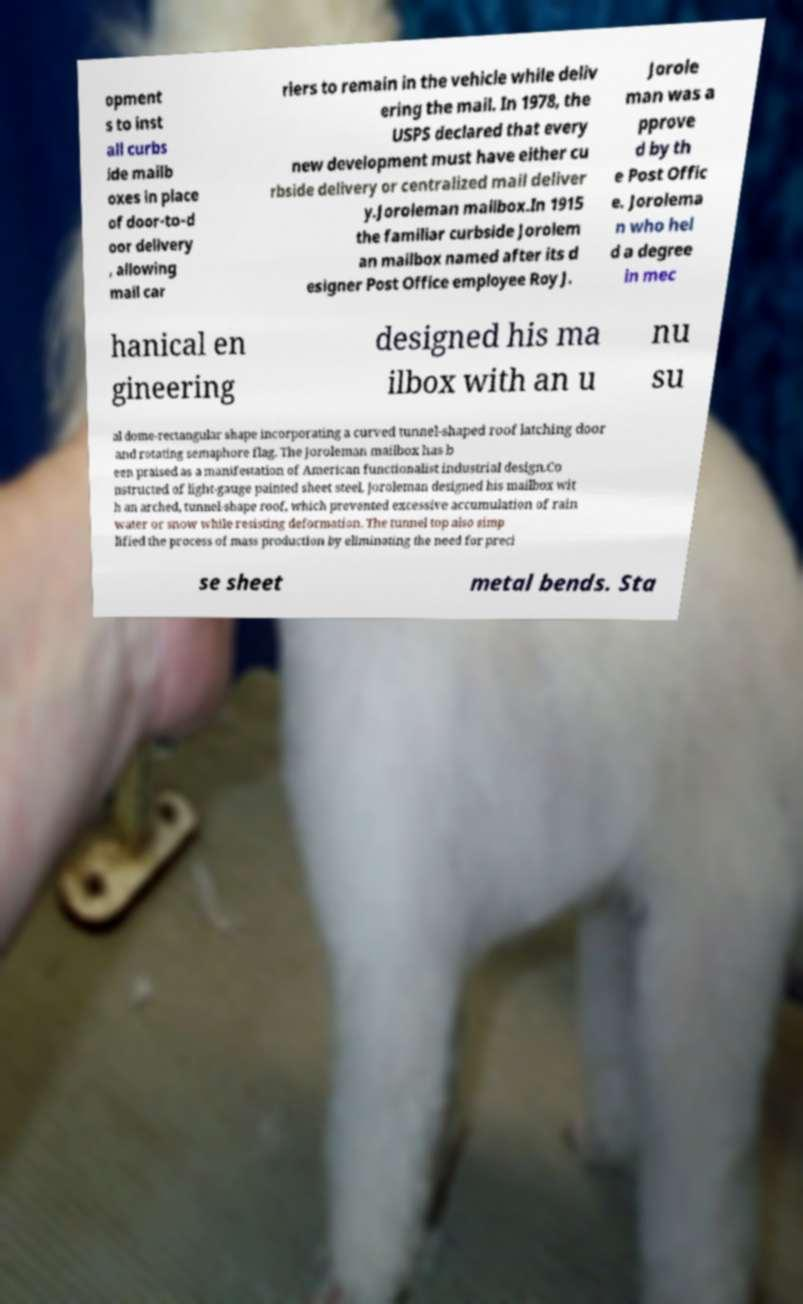Can you read and provide the text displayed in the image?This photo seems to have some interesting text. Can you extract and type it out for me? opment s to inst all curbs ide mailb oxes in place of door-to-d oor delivery , allowing mail car riers to remain in the vehicle while deliv ering the mail. In 1978, the USPS declared that every new development must have either cu rbside delivery or centralized mail deliver y.Joroleman mailbox.In 1915 the familiar curbside Jorolem an mailbox named after its d esigner Post Office employee Roy J. Jorole man was a pprove d by th e Post Offic e. Jorolema n who hel d a degree in mec hanical en gineering designed his ma ilbox with an u nu su al dome-rectangular shape incorporating a curved tunnel-shaped roof latching door and rotating semaphore flag. The Joroleman mailbox has b een praised as a manifestation of American functionalist industrial design.Co nstructed of light-gauge painted sheet steel, Joroleman designed his mailbox wit h an arched, tunnel-shape roof, which prevented excessive accumulation of rain water or snow while resisting deformation. The tunnel top also simp lified the process of mass production by eliminating the need for preci se sheet metal bends. Sta 